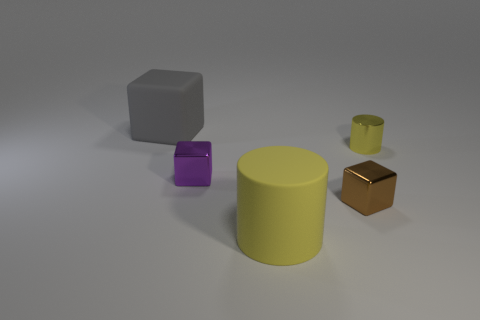Can you describe the atmosphere or mood of the setting depicted in the image? The setting appears calm and simplistic, with a soft light that suggests a peaceful, almost sterile environment. 